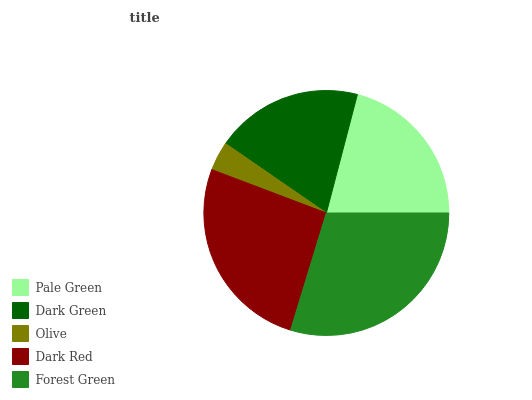Is Olive the minimum?
Answer yes or no. Yes. Is Forest Green the maximum?
Answer yes or no. Yes. Is Dark Green the minimum?
Answer yes or no. No. Is Dark Green the maximum?
Answer yes or no. No. Is Pale Green greater than Dark Green?
Answer yes or no. Yes. Is Dark Green less than Pale Green?
Answer yes or no. Yes. Is Dark Green greater than Pale Green?
Answer yes or no. No. Is Pale Green less than Dark Green?
Answer yes or no. No. Is Pale Green the high median?
Answer yes or no. Yes. Is Pale Green the low median?
Answer yes or no. Yes. Is Olive the high median?
Answer yes or no. No. Is Dark Green the low median?
Answer yes or no. No. 